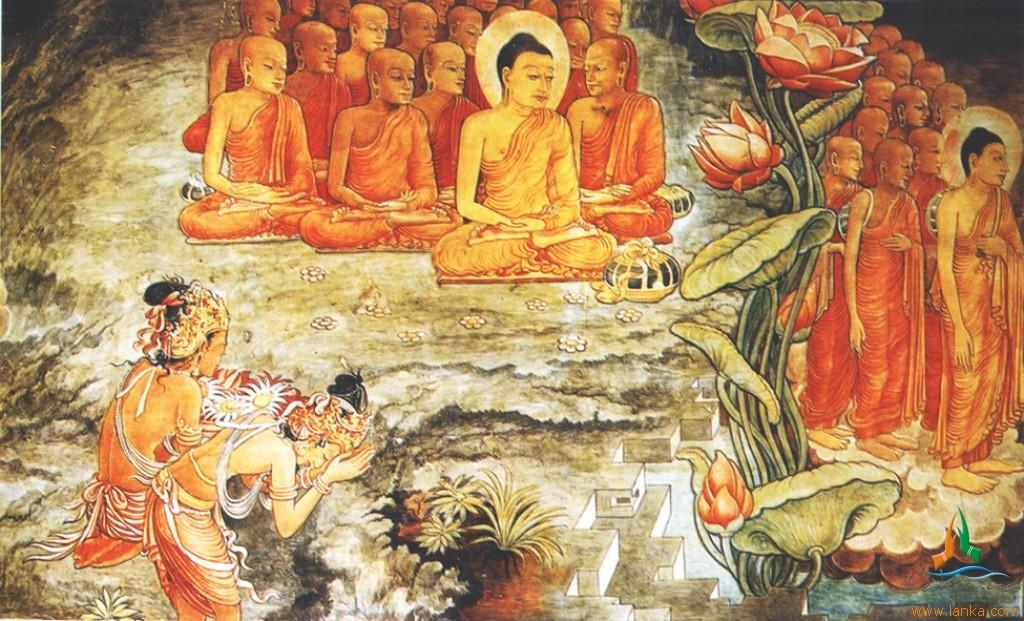What is the main subject of the image? The image contains a painting. What is depicted in the painting? The painting depicts people and includes flowers and leaves. Where can text be found in the image? There is text in the bottom right side of the image. How many slaves are depicted in the painting? There are no slaves depicted in the painting; it features people, flowers, and leaves. What event is being celebrated in the painting? The painting does not depict a specific event, such as a birth or a visitor. It simply shows people, flowers, and leaves. 